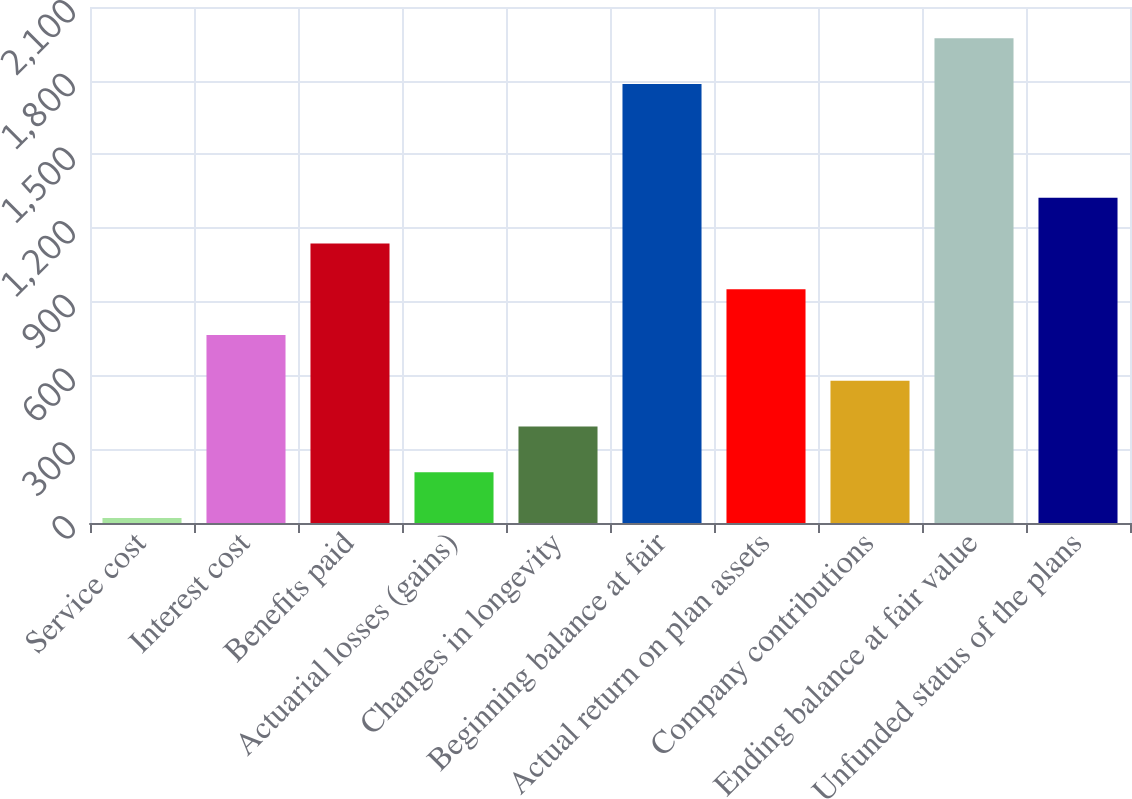Convert chart to OTSL. <chart><loc_0><loc_0><loc_500><loc_500><bar_chart><fcel>Service cost<fcel>Interest cost<fcel>Benefits paid<fcel>Actuarial losses (gains)<fcel>Changes in longevity<fcel>Beginning balance at fair<fcel>Actual return on plan assets<fcel>Company contributions<fcel>Ending balance at fair value<fcel>Unfunded status of the plans<nl><fcel>20<fcel>765.2<fcel>1137.8<fcel>206.3<fcel>392.6<fcel>1787<fcel>951.5<fcel>578.9<fcel>1973.3<fcel>1324.1<nl></chart> 